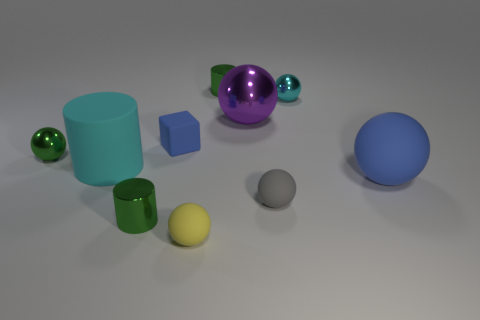What is the size of the yellow sphere?
Make the answer very short. Small. What is the color of the big ball that is the same material as the tiny cyan object?
Keep it short and to the point. Purple. What number of yellow matte spheres have the same size as the cyan matte cylinder?
Your answer should be very brief. 0. Does the small green cylinder that is behind the gray matte object have the same material as the green ball?
Offer a terse response. Yes. Are there fewer rubber spheres that are behind the big cylinder than cyan rubber cubes?
Your answer should be very brief. No. What shape is the big object that is on the right side of the tiny cyan ball?
Ensure brevity in your answer.  Sphere. The cyan object that is the same size as the purple object is what shape?
Your answer should be compact. Cylinder. Is there a small blue rubber thing that has the same shape as the large cyan matte thing?
Keep it short and to the point. No. There is a green thing that is behind the block; is its shape the same as the blue rubber object that is behind the big matte ball?
Your response must be concise. No. What material is the blue thing that is the same size as the cyan rubber cylinder?
Make the answer very short. Rubber. 